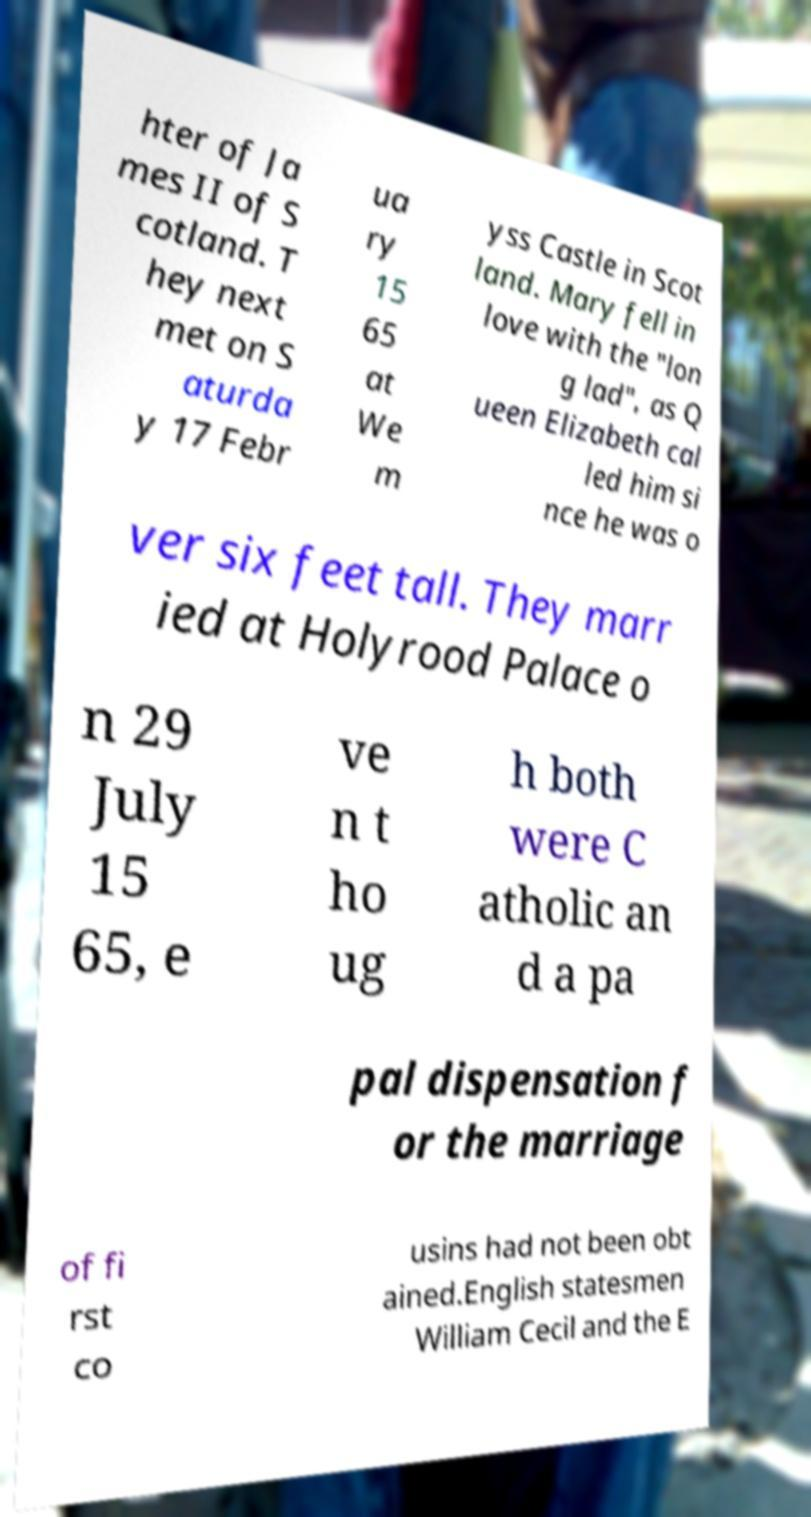Could you extract and type out the text from this image? hter of Ja mes II of S cotland. T hey next met on S aturda y 17 Febr ua ry 15 65 at We m yss Castle in Scot land. Mary fell in love with the "lon g lad", as Q ueen Elizabeth cal led him si nce he was o ver six feet tall. They marr ied at Holyrood Palace o n 29 July 15 65, e ve n t ho ug h both were C atholic an d a pa pal dispensation f or the marriage of fi rst co usins had not been obt ained.English statesmen William Cecil and the E 